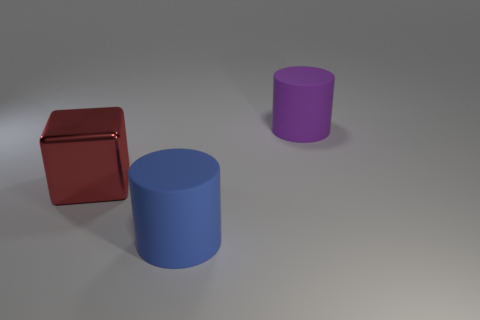What is the shape of the purple object that is made of the same material as the large blue object? cylinder 